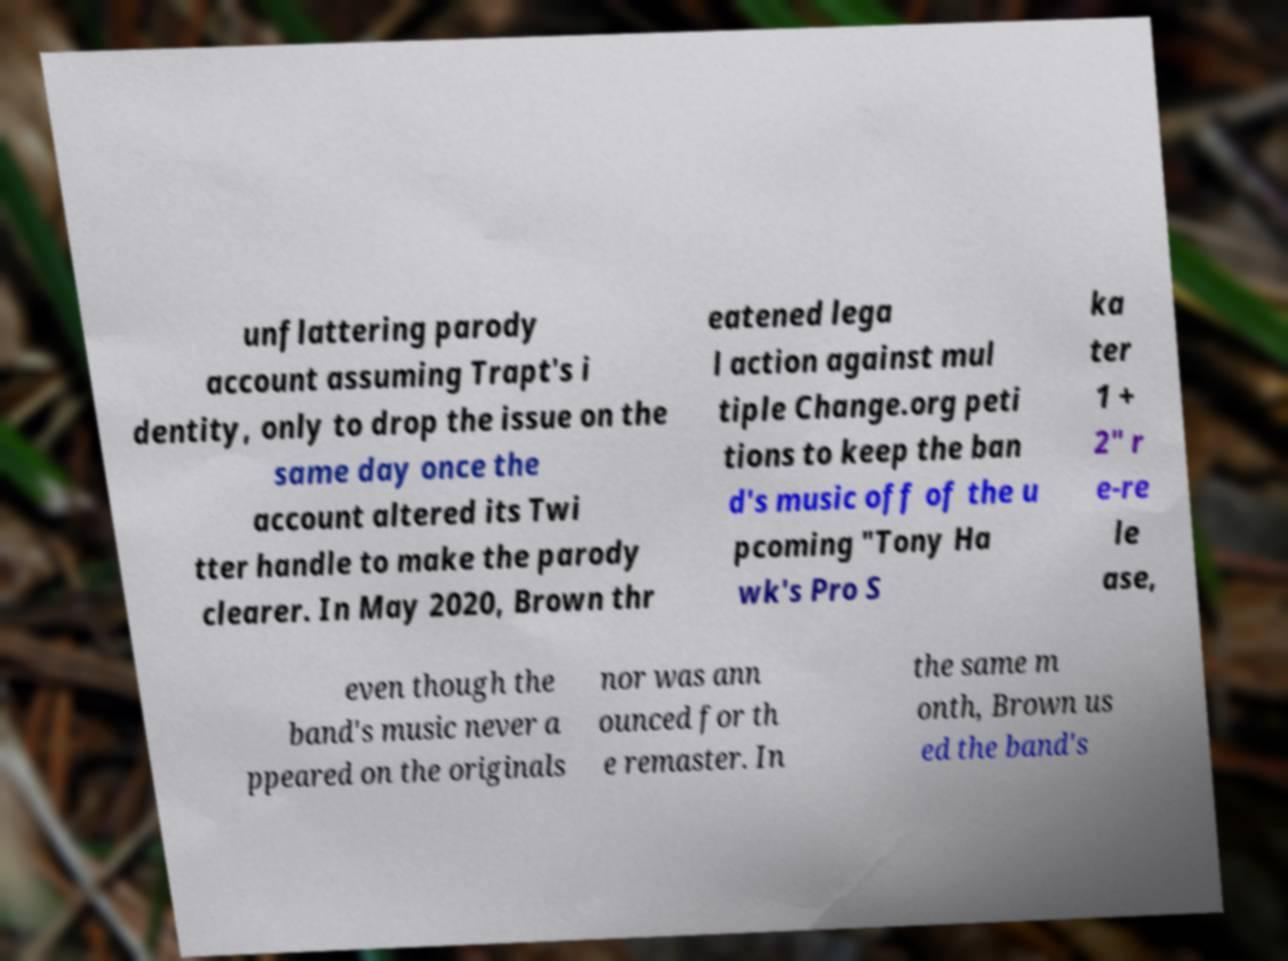Please read and relay the text visible in this image. What does it say? unflattering parody account assuming Trapt's i dentity, only to drop the issue on the same day once the account altered its Twi tter handle to make the parody clearer. In May 2020, Brown thr eatened lega l action against mul tiple Change.org peti tions to keep the ban d's music off of the u pcoming "Tony Ha wk's Pro S ka ter 1 + 2" r e-re le ase, even though the band's music never a ppeared on the originals nor was ann ounced for th e remaster. In the same m onth, Brown us ed the band's 